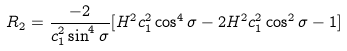<formula> <loc_0><loc_0><loc_500><loc_500>R _ { 2 } = \frac { - 2 } { c _ { 1 } ^ { 2 } \sin ^ { 4 } \sigma } [ H ^ { 2 } c _ { 1 } ^ { 2 } \cos ^ { 4 } \sigma - 2 H ^ { 2 } c _ { 1 } ^ { 2 } \cos ^ { 2 } \sigma - 1 ]</formula> 